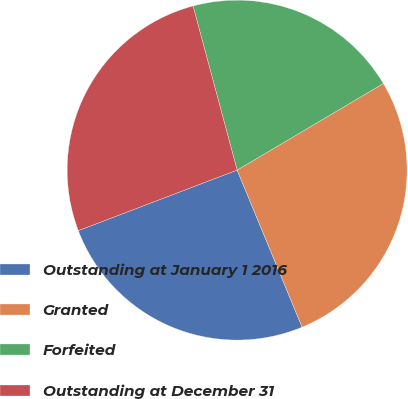<chart> <loc_0><loc_0><loc_500><loc_500><pie_chart><fcel>Outstanding at January 1 2016<fcel>Granted<fcel>Forfeited<fcel>Outstanding at December 31<nl><fcel>25.45%<fcel>27.27%<fcel>20.67%<fcel>26.62%<nl></chart> 